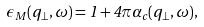<formula> <loc_0><loc_0><loc_500><loc_500>\epsilon _ { M } ( { q } _ { \perp } , \omega ) = 1 + 4 \pi \alpha _ { c } ( { q } _ { \perp } , \omega ) ,</formula> 